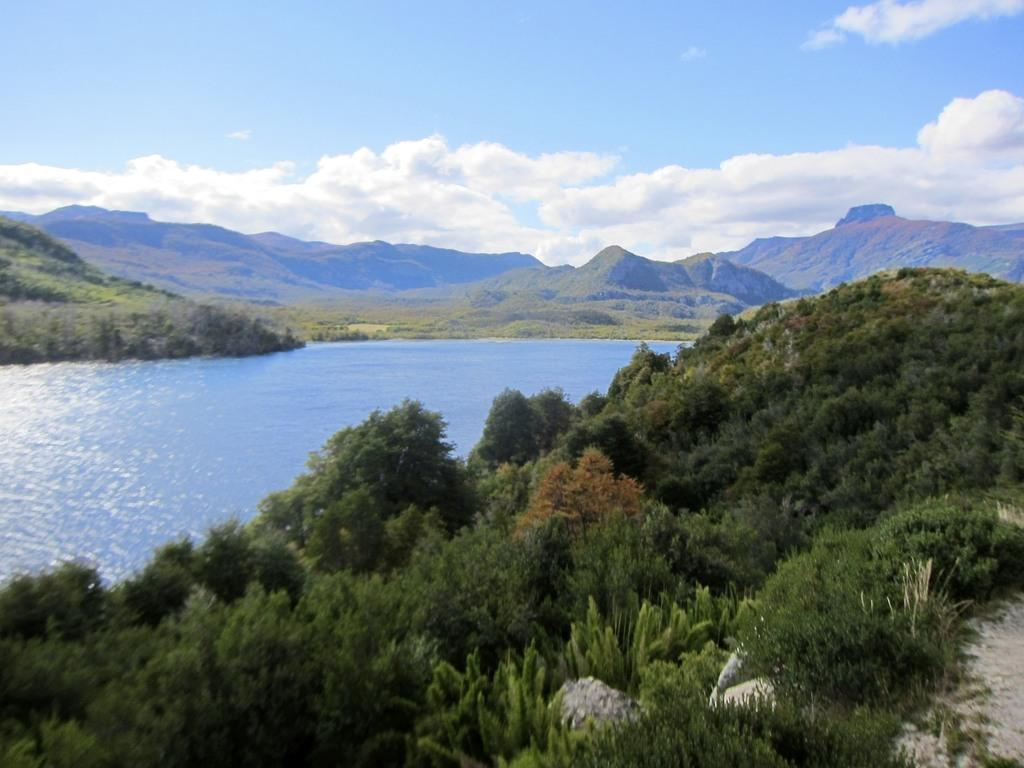What type of vegetation can be seen in the foreground of the image? There is greenery in the foreground of the image. What natural element is visible in the image besides the greenery? There is water visible in the image. What type of landscape can be seen in the background of the image? There are mountains in the background of the image. What is visible above the mountains in the image? The sky is visible in the background of the image. How does the writer contribute to the quietness of the image? There is no writer present in the image, and therefore no contribution to the quietness can be observed. 